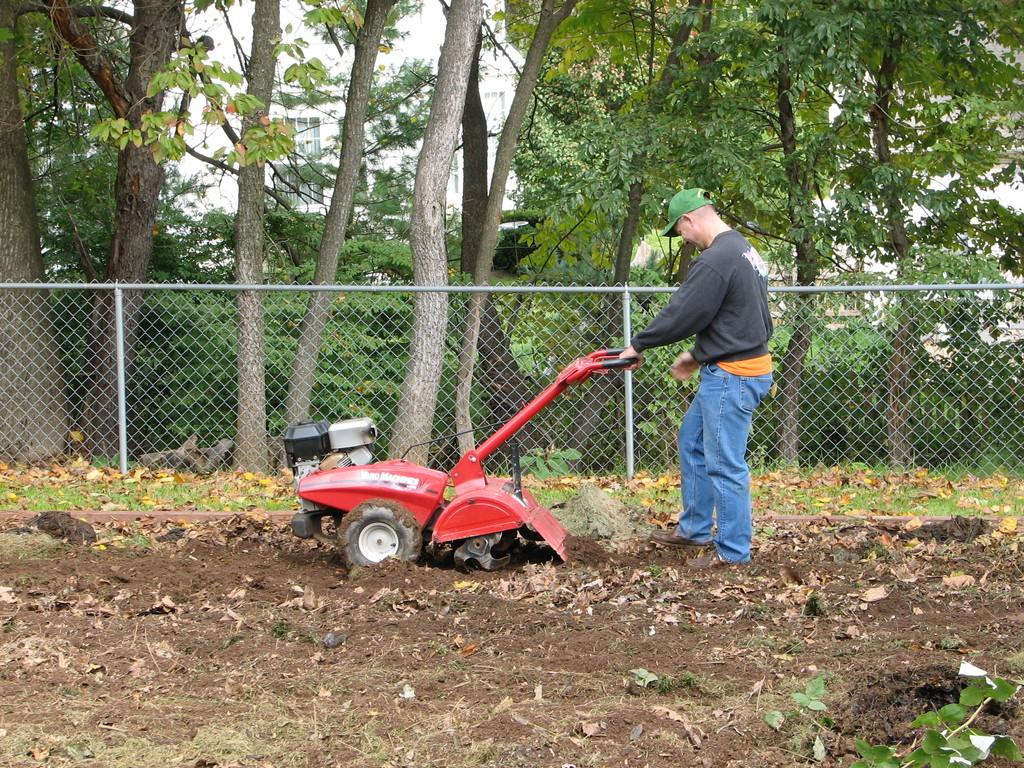What is the person in the image holding? The person is holding a drill in the image. What can be seen in the background of the image? There are trees and a fence in the background of the image. What is visible at the bottom of the image? The ground is visible at the bottom of the image. How many rings are visible on the person's fingers in the image? There are no rings visible on the person's fingers in the image. What type of shoes is the person wearing in the image? The person's shoes are not visible in the image. 